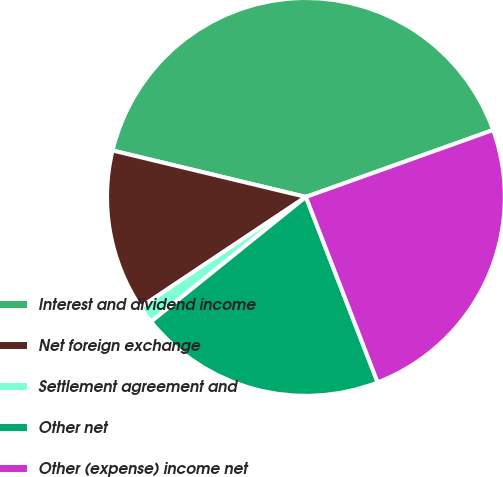Convert chart. <chart><loc_0><loc_0><loc_500><loc_500><pie_chart><fcel>Interest and dividend income<fcel>Net foreign exchange<fcel>Settlement agreement and<fcel>Other net<fcel>Other (expense) income net<nl><fcel>40.78%<fcel>13.11%<fcel>1.43%<fcel>20.08%<fcel>24.59%<nl></chart> 